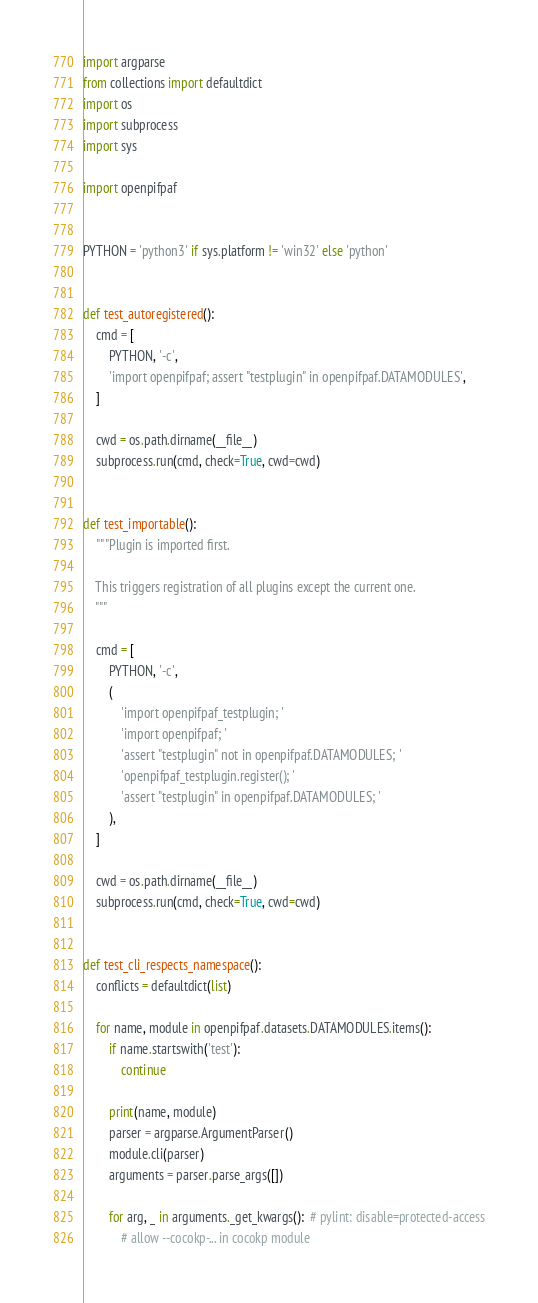<code> <loc_0><loc_0><loc_500><loc_500><_Python_>import argparse
from collections import defaultdict
import os
import subprocess
import sys

import openpifpaf


PYTHON = 'python3' if sys.platform != 'win32' else 'python'


def test_autoregistered():
    cmd = [
        PYTHON, '-c',
        'import openpifpaf; assert "testplugin" in openpifpaf.DATAMODULES',
    ]

    cwd = os.path.dirname(__file__)
    subprocess.run(cmd, check=True, cwd=cwd)


def test_importable():
    """Plugin is imported first.

    This triggers registration of all plugins except the current one.
    """

    cmd = [
        PYTHON, '-c',
        (
            'import openpifpaf_testplugin; '
            'import openpifpaf; '
            'assert "testplugin" not in openpifpaf.DATAMODULES; '
            'openpifpaf_testplugin.register(); '
            'assert "testplugin" in openpifpaf.DATAMODULES; '
        ),
    ]

    cwd = os.path.dirname(__file__)
    subprocess.run(cmd, check=True, cwd=cwd)


def test_cli_respects_namespace():
    conflicts = defaultdict(list)

    for name, module in openpifpaf.datasets.DATAMODULES.items():
        if name.startswith('test'):
            continue

        print(name, module)
        parser = argparse.ArgumentParser()
        module.cli(parser)
        arguments = parser.parse_args([])

        for arg, _ in arguments._get_kwargs():  # pylint: disable=protected-access
            # allow --cocokp-... in cocokp module</code> 